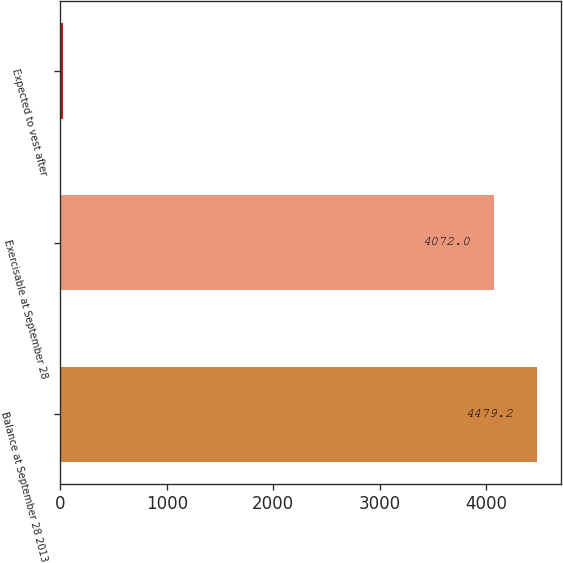Convert chart. <chart><loc_0><loc_0><loc_500><loc_500><bar_chart><fcel>Balance at September 28 2013<fcel>Exercisable at September 28<fcel>Expected to vest after<nl><fcel>4479.2<fcel>4072<fcel>22<nl></chart> 